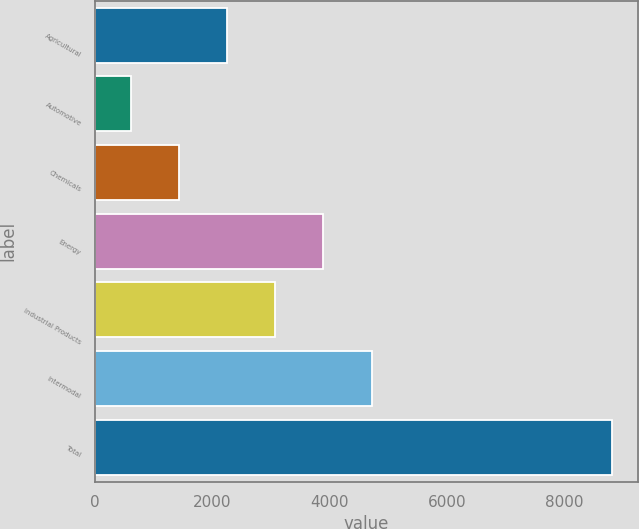Convert chart to OTSL. <chart><loc_0><loc_0><loc_500><loc_500><bar_chart><fcel>Agricultural<fcel>Automotive<fcel>Chemicals<fcel>Energy<fcel>Industrial Products<fcel>Intermodal<fcel>Total<nl><fcel>2251.8<fcel>611<fcel>1431.4<fcel>3892.6<fcel>3072.2<fcel>4713<fcel>8815<nl></chart> 